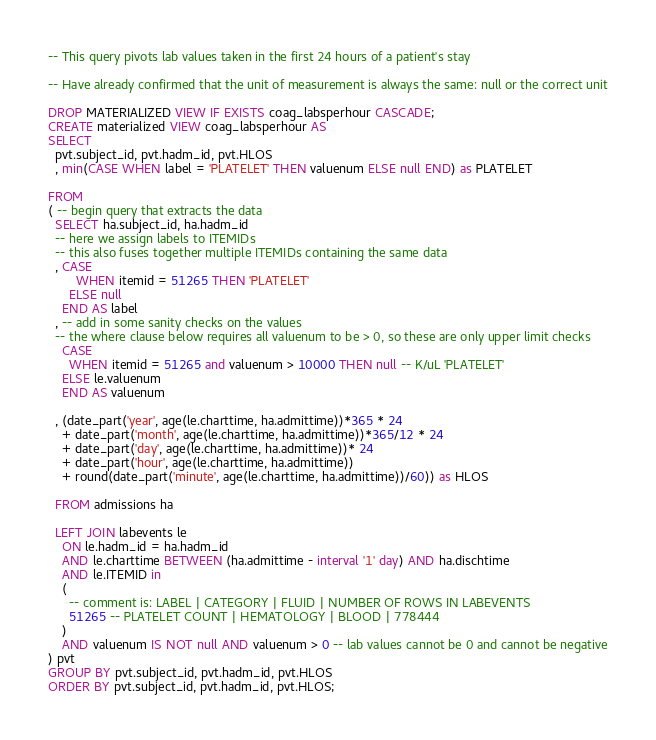Convert code to text. <code><loc_0><loc_0><loc_500><loc_500><_SQL_>-- This query pivots lab values taken in the first 24 hours of a patient's stay

-- Have already confirmed that the unit of measurement is always the same: null or the correct unit

DROP MATERIALIZED VIEW IF EXISTS coag_labsperhour CASCADE;
CREATE materialized VIEW coag_labsperhour AS
SELECT
  pvt.subject_id, pvt.hadm_id, pvt.HLOS
  , min(CASE WHEN label = 'PLATELET' THEN valuenum ELSE null END) as PLATELET

FROM
( -- begin query that extracts the data
  SELECT ha.subject_id, ha.hadm_id
  -- here we assign labels to ITEMIDs
  -- this also fuses together multiple ITEMIDs containing the same data
  , CASE
        WHEN itemid = 51265 THEN 'PLATELET'
      ELSE null
    END AS label
  , -- add in some sanity checks on the values
  -- the where clause below requires all valuenum to be > 0, so these are only upper limit checks
    CASE
      WHEN itemid = 51265 and valuenum > 10000 THEN null -- K/uL 'PLATELET'
    ELSE le.valuenum
    END AS valuenum

  , (date_part('year', age(le.charttime, ha.admittime))*365 * 24
    + date_part('month', age(le.charttime, ha.admittime))*365/12 * 24
    + date_part('day', age(le.charttime, ha.admittime))* 24
    + date_part('hour', age(le.charttime, ha.admittime))
    + round(date_part('minute', age(le.charttime, ha.admittime))/60)) as HLOS

  FROM admissions ha

  LEFT JOIN labevents le
    ON le.hadm_id = ha.hadm_id
    AND le.charttime BETWEEN (ha.admittime - interval '1' day) AND ha.dischtime
    AND le.ITEMID in
    (
      -- comment is: LABEL | CATEGORY | FLUID | NUMBER OF ROWS IN LABEVENTS
      51265 -- PLATELET COUNT | HEMATOLOGY | BLOOD | 778444
    )
    AND valuenum IS NOT null AND valuenum > 0 -- lab values cannot be 0 and cannot be negative
) pvt
GROUP BY pvt.subject_id, pvt.hadm_id, pvt.HLOS
ORDER BY pvt.subject_id, pvt.hadm_id, pvt.HLOS;</code> 